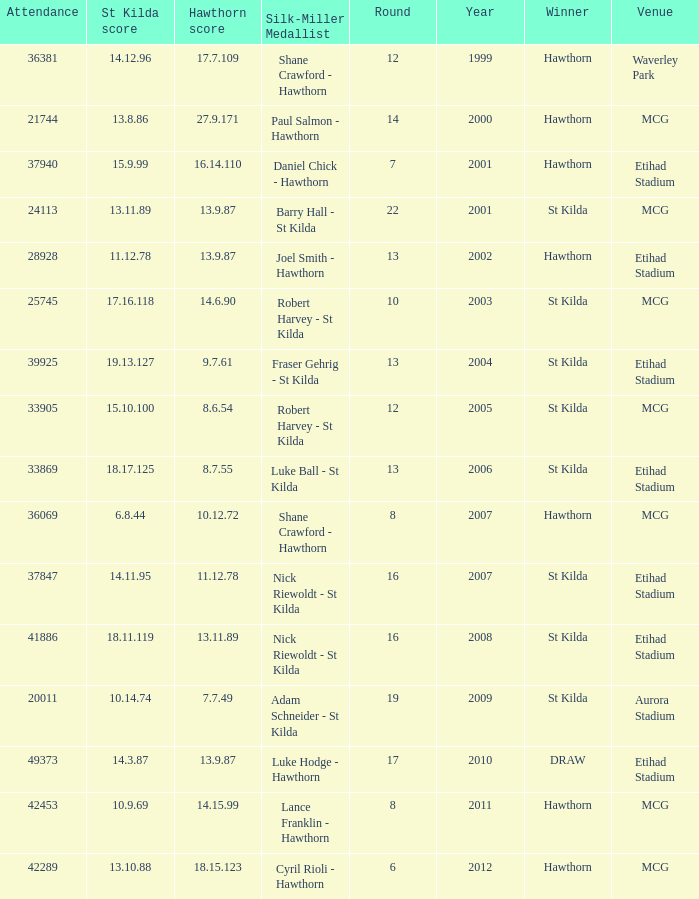What is the attendance when the hawthorn score is 18.15.123? 42289.0. 